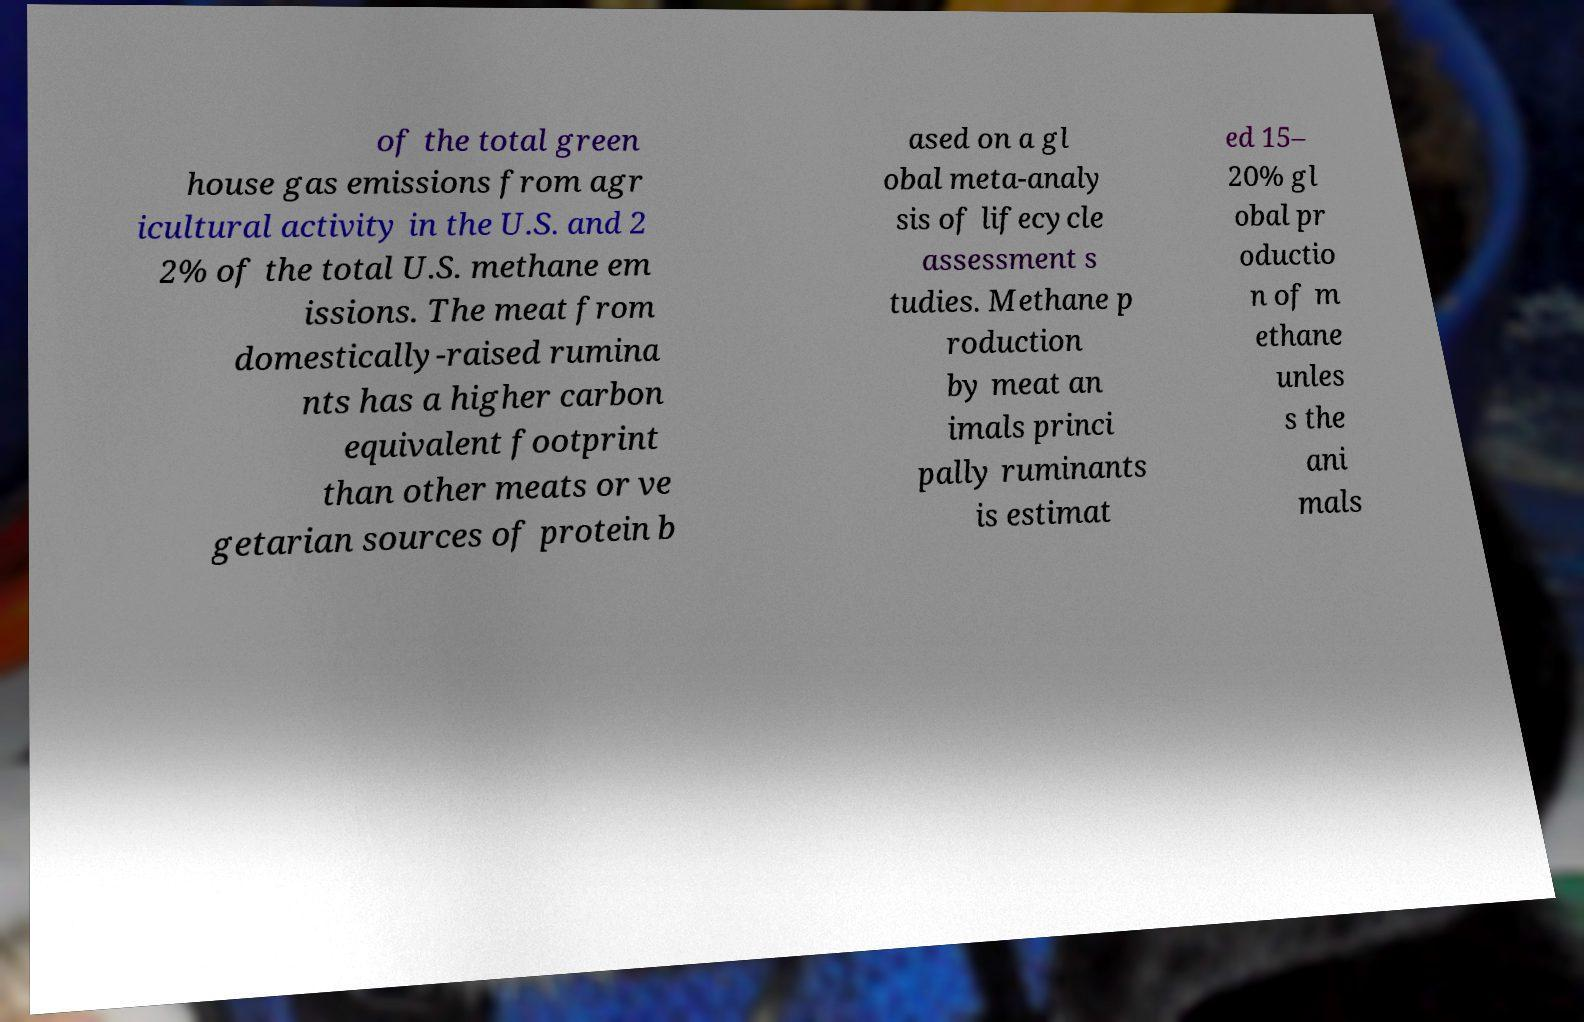Could you extract and type out the text from this image? of the total green house gas emissions from agr icultural activity in the U.S. and 2 2% of the total U.S. methane em issions. The meat from domestically-raised rumina nts has a higher carbon equivalent footprint than other meats or ve getarian sources of protein b ased on a gl obal meta-analy sis of lifecycle assessment s tudies. Methane p roduction by meat an imals princi pally ruminants is estimat ed 15– 20% gl obal pr oductio n of m ethane unles s the ani mals 